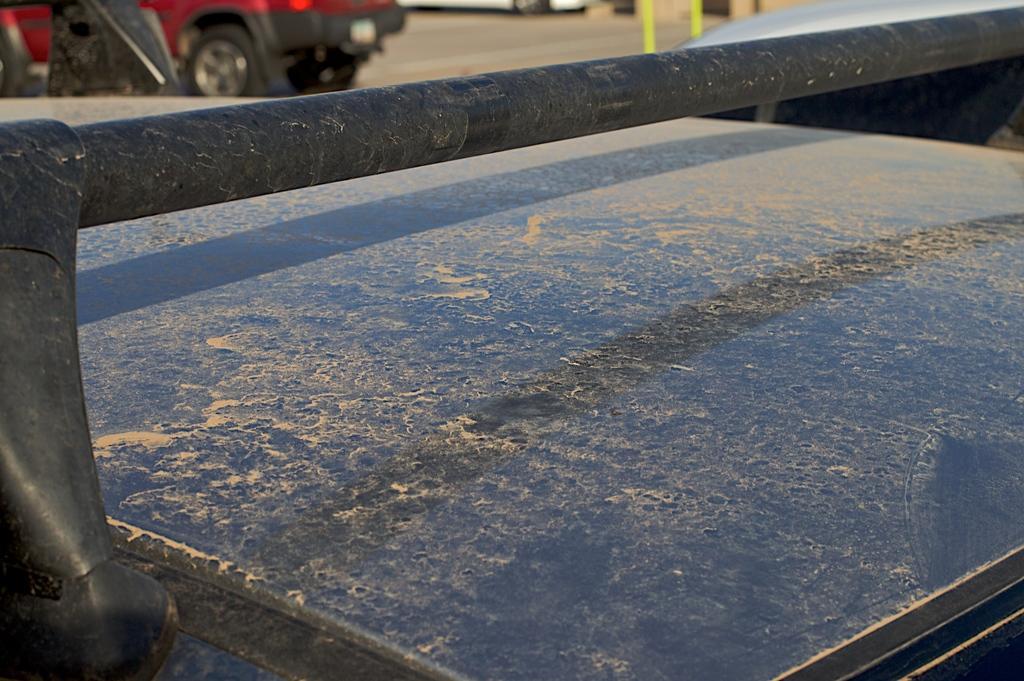How would you summarize this image in a sentence or two? At the bottom of the image we can see the top of a car. In the background there is another car which is parked on the road. 